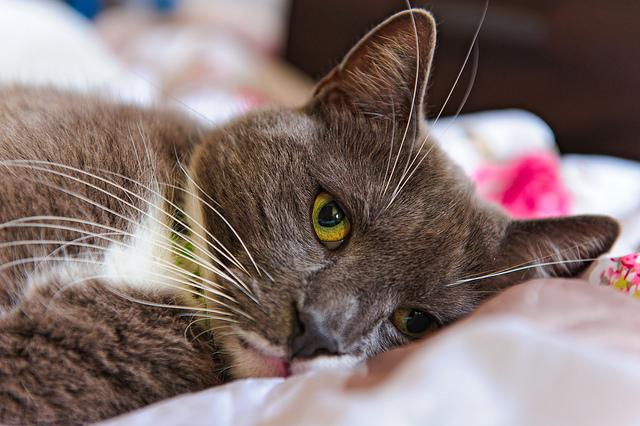What color are the cat's eyes?
Concise answer only. Yellow. What's are the colors is the cat?
Quick response, please. Gray and white. Is the cat lying on the floor?
Quick response, please. No. 